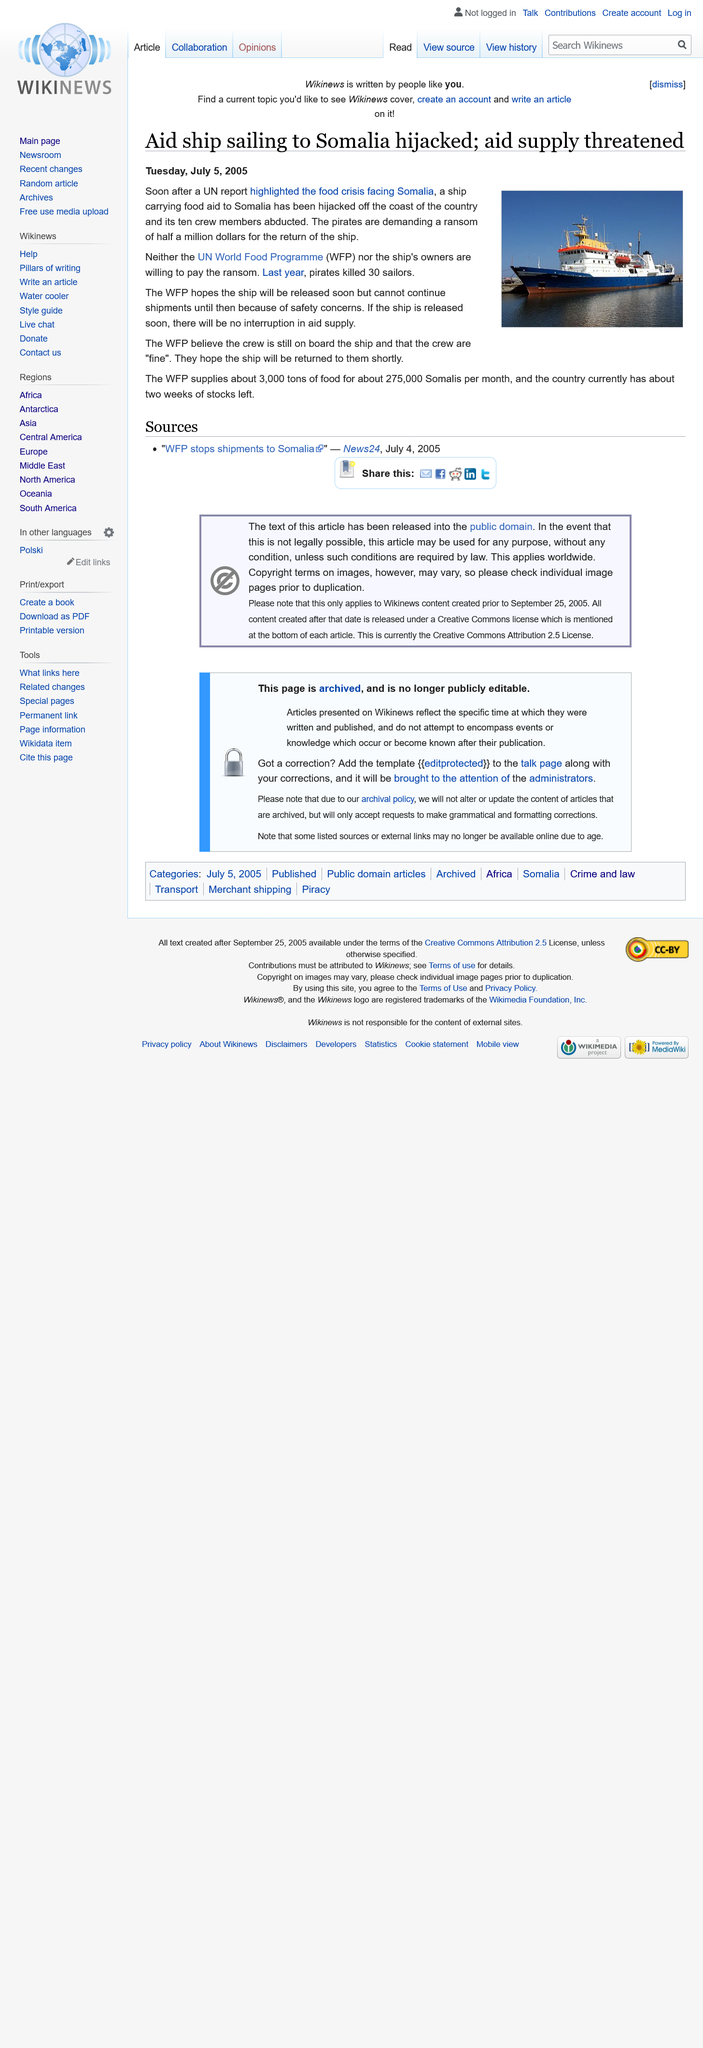Indicate a few pertinent items in this graphic. The United Nations report highlighted a dire food crisis facing the people of Somalia. The aid ship was sailing to Somalia from an unknown location. The World Food Program believes that the crew is still on board and in good condition. 